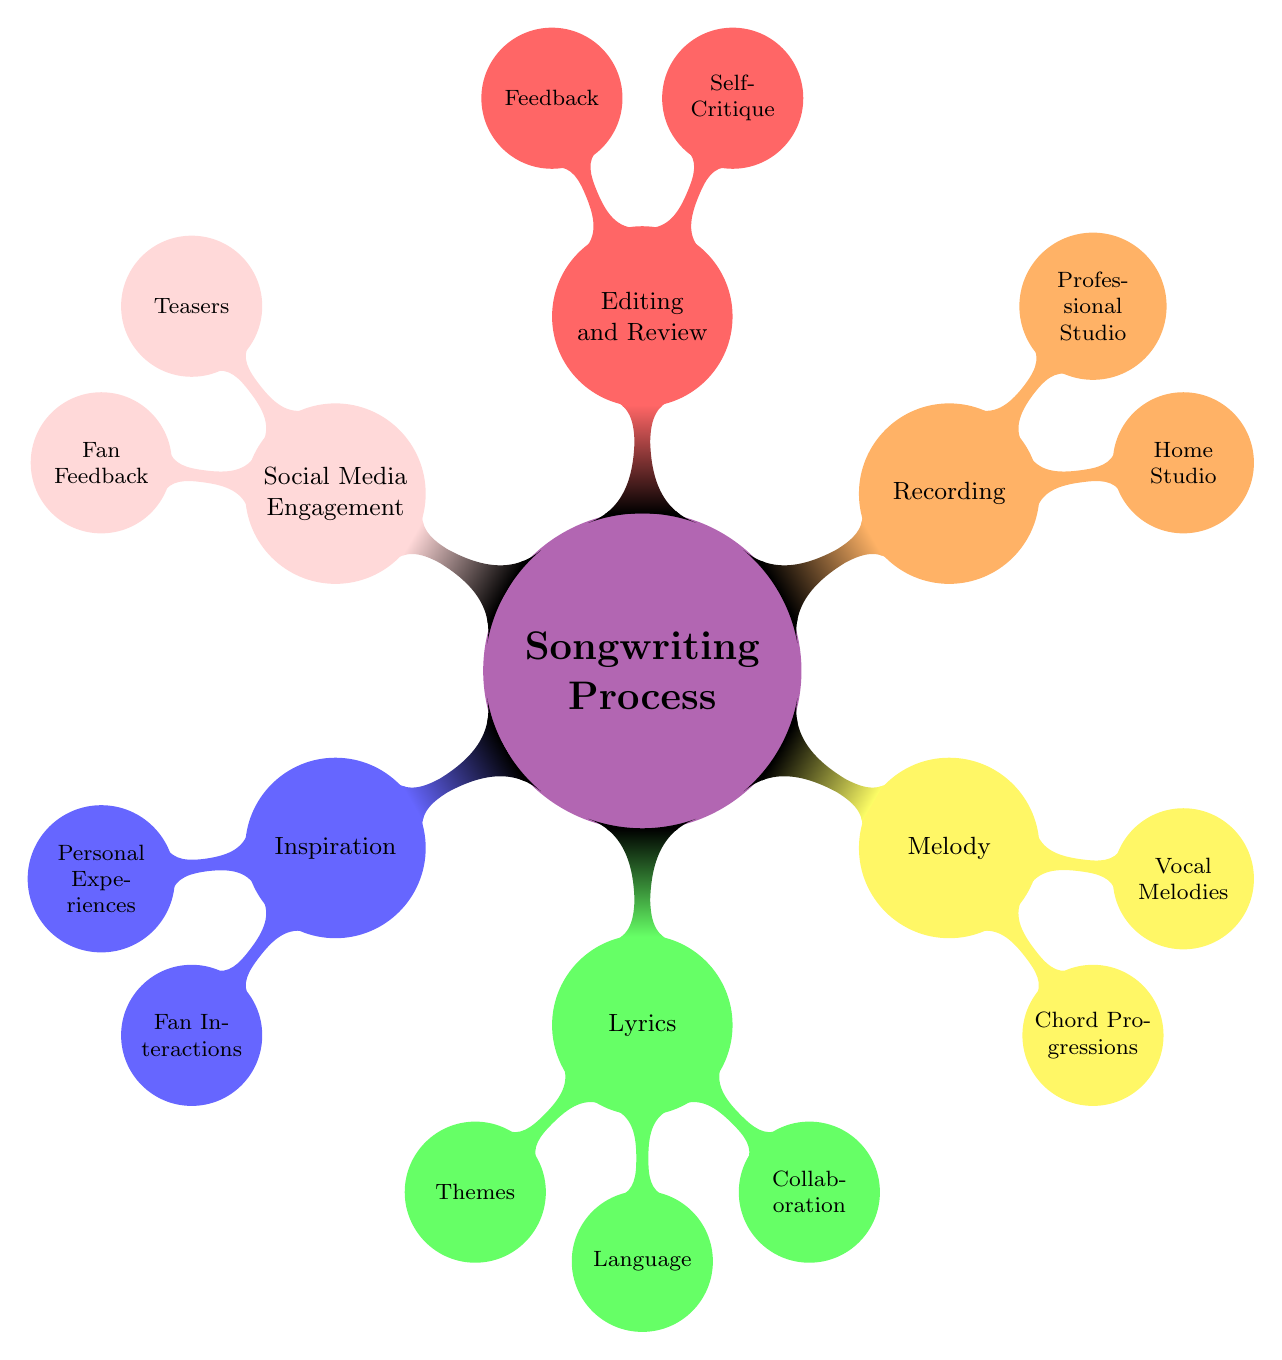What are the two main branches under the Songwriting Process? The main branches are Inspiration and Lyrics, which are the first-level nodes connected directly to the central node Songwriting Process.
Answer: Inspiration, Lyrics How many nodes are there in the Lyrics category? The Lyrics category has three nodes: Themes, Language, and Collaboration, making it a total of three.
Answer: 3 Which category includes both Home Studio and Professional Studio? The Recording category contains both nodes, categorizing where the recording of songs might happen.
Answer: Recording What type of feedback is sought during the Editing and Review phase? In the Editing and Review phase, feedback is gathered from team members and close friends, indicating who provides this feedback.
Answer: Team members, close friends How are personal experiences and fan interactions related in the diagram? Personal experiences and fan interactions are both under the Inspiration category, reflecting the sources of inspiration for songwriting.
Answer: Inspiration What type of content is shared as Teasers? Teasers include snippets and behind-the-scenes footage, indicating the kind of previews provided to fans.
Answer: Snippets, behind-the-scenes footage How many total child nodes are there in the Songwriting Process? The total number of child nodes includes all subcategories across different categories: Inspiration (2), Lyrics (3), Melody (2), Recording (2), Editing and Review (2), and Social Media Engagement (2), which totals to 13 nodes.
Answer: 13 What does the Collaboration node signify in the Lyrics section? The Collaboration node signifies participation with co-writers and producers in the process of crafting lyrics, highlighting the collaborative nature of this songwriting component.
Answer: Co-writers, producers What type of themes are discussed in the Lyrics section? The themes in the Lyrics section include love, empowerment, heartbreak, and social issues, showcasing the diverse subjects addressed in the writing.
Answer: Love, empowerment, heartbreak, social issues 